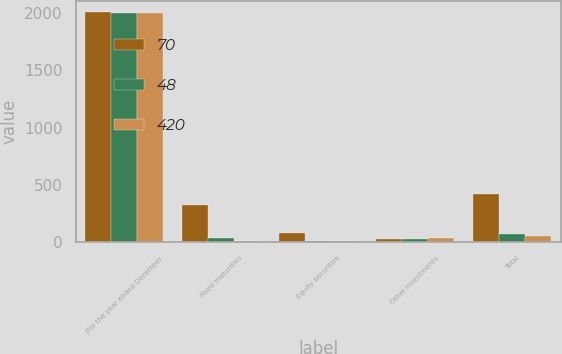Convert chart to OTSL. <chart><loc_0><loc_0><loc_500><loc_500><stacked_bar_chart><ecel><fcel>(for the year ended December<fcel>Fixed maturities<fcel>Equity securities<fcel>Other investments<fcel>Total<nl><fcel>70<fcel>2008<fcel>324<fcel>74<fcel>22<fcel>420<nl><fcel>48<fcel>2007<fcel>37<fcel>7<fcel>26<fcel>70<nl><fcel>420<fcel>2006<fcel>7<fcel>4<fcel>37<fcel>48<nl></chart> 